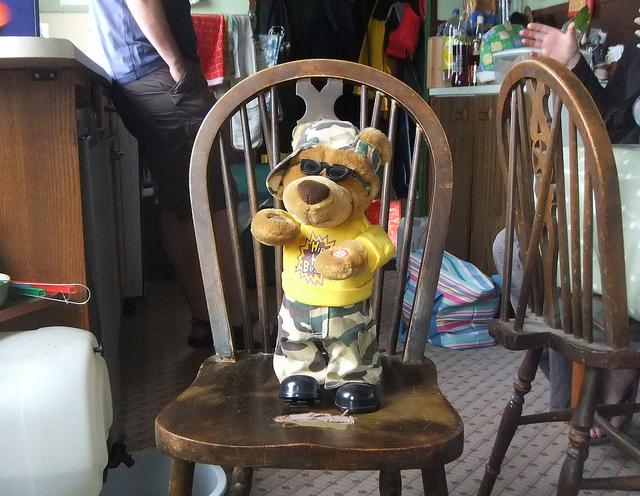What is this bear doing?
Short answer required. Standing. How many fingers are visible on the combined two humans?
Concise answer only. 4. Have the chairs been recently varnished?
Give a very brief answer. No. 